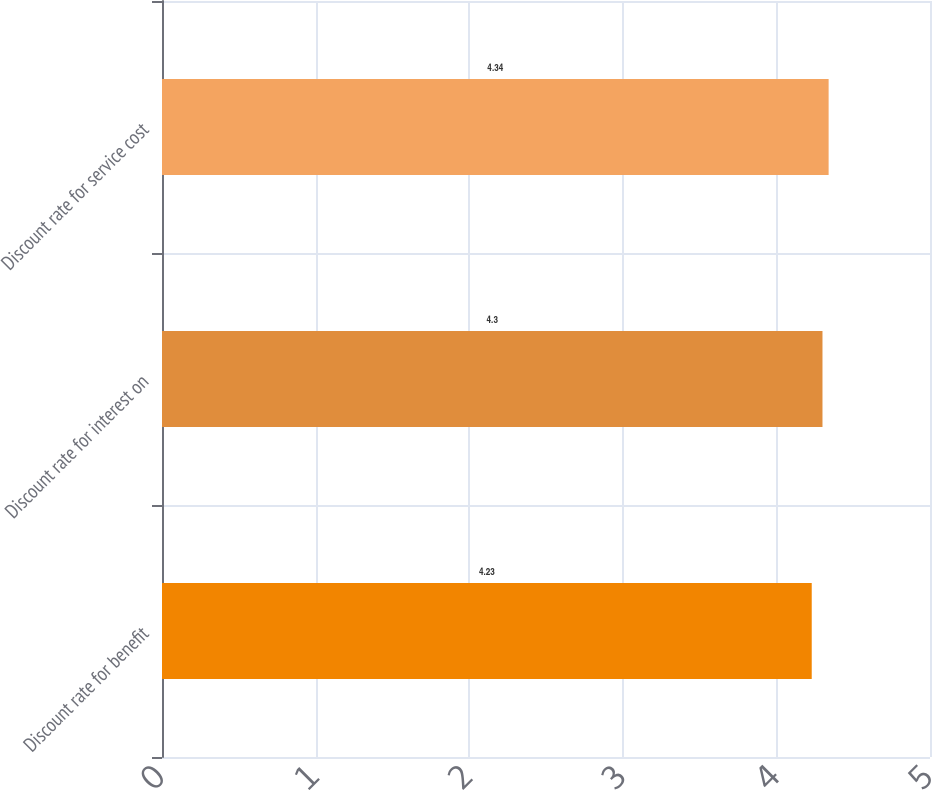Convert chart. <chart><loc_0><loc_0><loc_500><loc_500><bar_chart><fcel>Discount rate for benefit<fcel>Discount rate for interest on<fcel>Discount rate for service cost<nl><fcel>4.23<fcel>4.3<fcel>4.34<nl></chart> 